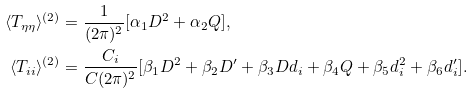Convert formula to latex. <formula><loc_0><loc_0><loc_500><loc_500>\langle T _ { \eta \eta } \rangle ^ { ( 2 ) } & = \frac { 1 } { ( 2 \pi ) ^ { 2 } } [ \alpha _ { 1 } D ^ { 2 } + \alpha _ { 2 } Q ] , \\ \langle T _ { i i } \rangle ^ { ( 2 ) } & = \frac { C _ { i } } { C ( 2 \pi ) ^ { 2 } } [ \beta _ { 1 } D ^ { 2 } + \beta _ { 2 } D ^ { \prime } + \beta _ { 3 } D d _ { i } + \beta _ { 4 } Q + \beta _ { 5 } d _ { i } ^ { 2 } + \beta _ { 6 } d _ { i } ^ { \prime } ] .</formula> 